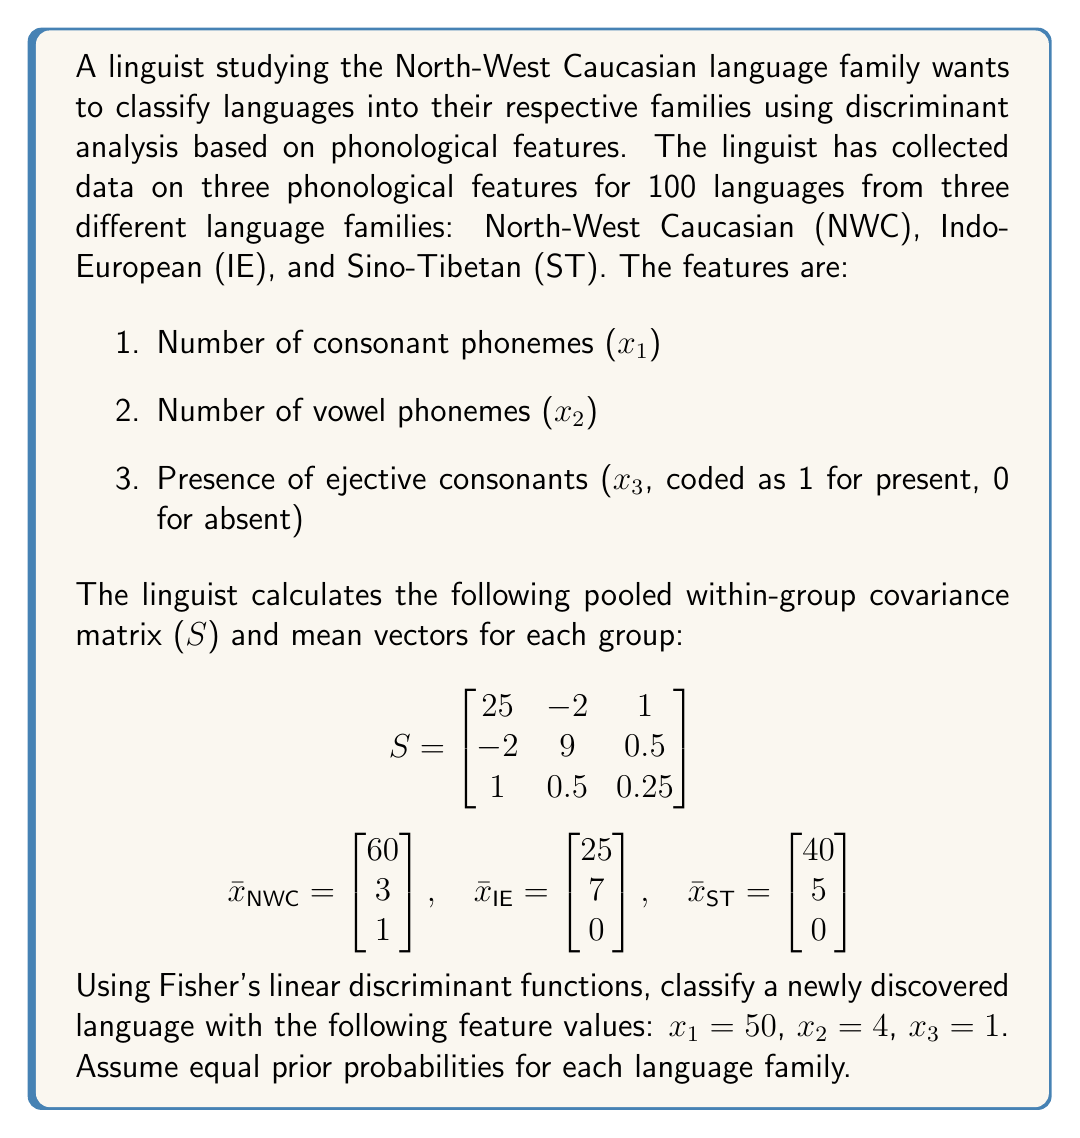Teach me how to tackle this problem. To classify the newly discovered language using Fisher's linear discriminant functions, we need to follow these steps:

1. Calculate the linear discriminant function for each group (language family).
2. Evaluate each function for the new language's feature values.
3. Assign the language to the group with the highest discriminant score.

The linear discriminant function for group i is given by:

$$L_i(x) = \bar{x}_i^T S^{-1}x - \frac{1}{2}\bar{x}_i^T S^{-1}\bar{x}_i + \ln(p_i)$$

where $\bar{x}_i$ is the mean vector for group i, S is the pooled within-group covariance matrix, x is the feature vector of the new language, and $p_i$ is the prior probability for group i.

Step 1: Calculate $S^{-1}$

$$S^{-1} = \begin{bmatrix}
0.0408 & 0.0089 & -0.1633 \\
0.0089 & 0.1133 & -0.0244 \\
-0.1633 & -0.0244 & 4.1789
\end{bmatrix}$$

Step 2: Calculate $\bar{x}_i^T S^{-1}$ for each group

For NWC: $[2.5347, 0.3941, 3.7912]$
For IE: $[1.0478, 0.7964, -0.1633]$
For ST: $[1.6728, 0.5686, -0.1633]$

Step 3: Calculate $\frac{1}{2}\bar{x}_i^T S^{-1}\bar{x}_i$ for each group

For NWC: 154.7059
For IE: 27.9348
For ST: 67.2712

Step 4: Calculate the linear discriminant functions

$$L_{NWC}(x) = 2.5347x_1 + 0.3941x_2 + 3.7912x_3 - 154.7059 + \ln(\frac{1}{3})$$
$$L_{IE}(x) = 1.0478x_1 + 0.7964x_2 - 0.1633x_3 - 27.9348 + \ln(\frac{1}{3})$$
$$L_{ST}(x) = 1.6728x_1 + 0.5686x_2 - 0.1633x_3 - 67.2712 + \ln(\frac{1}{3})$$

Step 5: Evaluate the functions for the new language (50, 4, 1)

$$L_{NWC}(50, 4, 1) = 126.735 + 1.5764 + 3.7912 - 154.7059 - 1.0986 = -23.7019$$
$$L_{IE}(50, 4, 1) = 52.39 + 3.1856 - 0.1633 - 27.9348 - 1.0986 = 26.3789$$
$$L_{ST}(50, 4, 1) = 83.64 + 2.2744 - 0.1633 - 67.2712 - 1.0986 = 17.3813$$

Step 6: Assign the language to the group with the highest discriminant score
Answer: The newly discovered language should be classified as Indo-European (IE) because it has the highest discriminant score of 26.3789. 